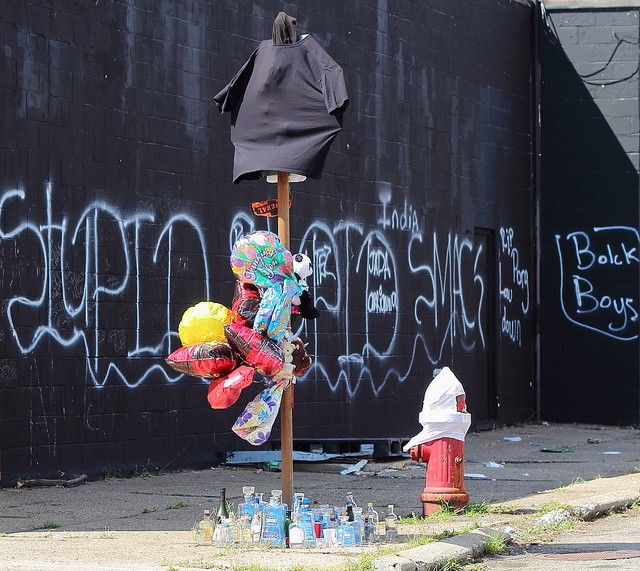Describe the objects in this image and their specific colors. I can see fire hydrant in black, white, salmon, and brown tones, bottle in black, lightgray, lightblue, and darkgray tones, teddy bear in black, lavender, darkgray, and gray tones, bottle in black, darkgray, gray, lightgray, and beige tones, and teddy bear in black, maroon, and brown tones in this image. 